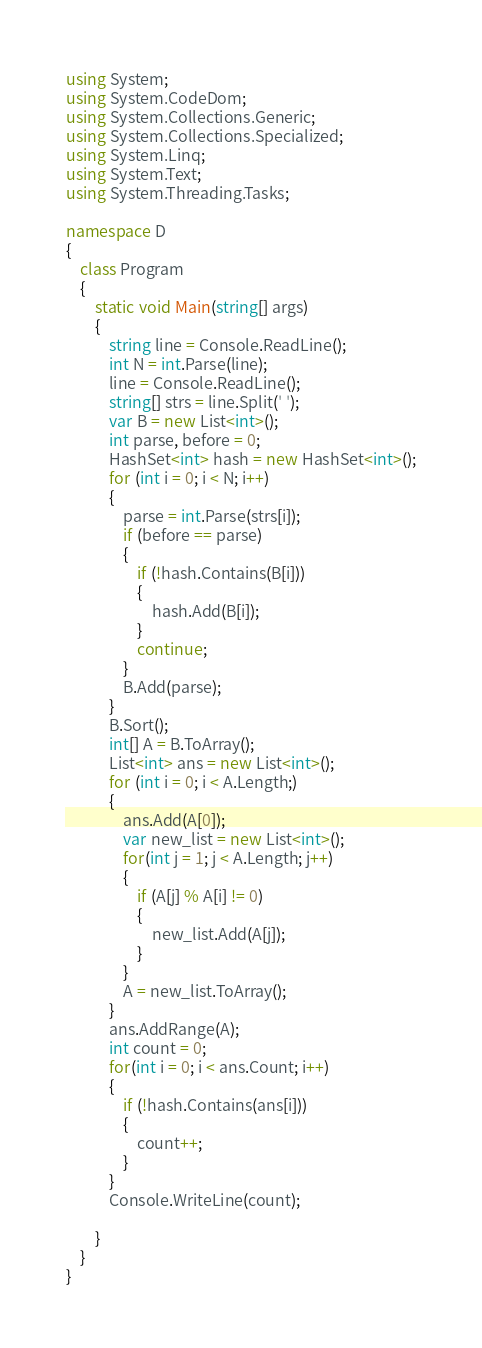Convert code to text. <code><loc_0><loc_0><loc_500><loc_500><_C#_>using System;
using System.CodeDom;
using System.Collections.Generic;
using System.Collections.Specialized;
using System.Linq;
using System.Text;
using System.Threading.Tasks;

namespace D
{
    class Program
    {
        static void Main(string[] args)
        {
            string line = Console.ReadLine();
            int N = int.Parse(line);
            line = Console.ReadLine();
            string[] strs = line.Split(' ');
            var B = new List<int>();
            int parse, before = 0;
            HashSet<int> hash = new HashSet<int>();
            for (int i = 0; i < N; i++)
            {
                parse = int.Parse(strs[i]);
                if (before == parse)
                {
                    if (!hash.Contains(B[i]))
                    {
                        hash.Add(B[i]);
                    }
                    continue;
                }
                B.Add(parse);
            }
            B.Sort();
            int[] A = B.ToArray();
            List<int> ans = new List<int>();
            for (int i = 0; i < A.Length;)
            {
                ans.Add(A[0]);
                var new_list = new List<int>();
                for(int j = 1; j < A.Length; j++)
                {
                    if (A[j] % A[i] != 0)
                    {
                        new_list.Add(A[j]);
                    }
                }
                A = new_list.ToArray();
            }
            ans.AddRange(A);
            int count = 0;
            for(int i = 0; i < ans.Count; i++)
            {
                if (!hash.Contains(ans[i]))
                {
                    count++;
                }
            }
            Console.WriteLine(count);

        }
    }
}
</code> 